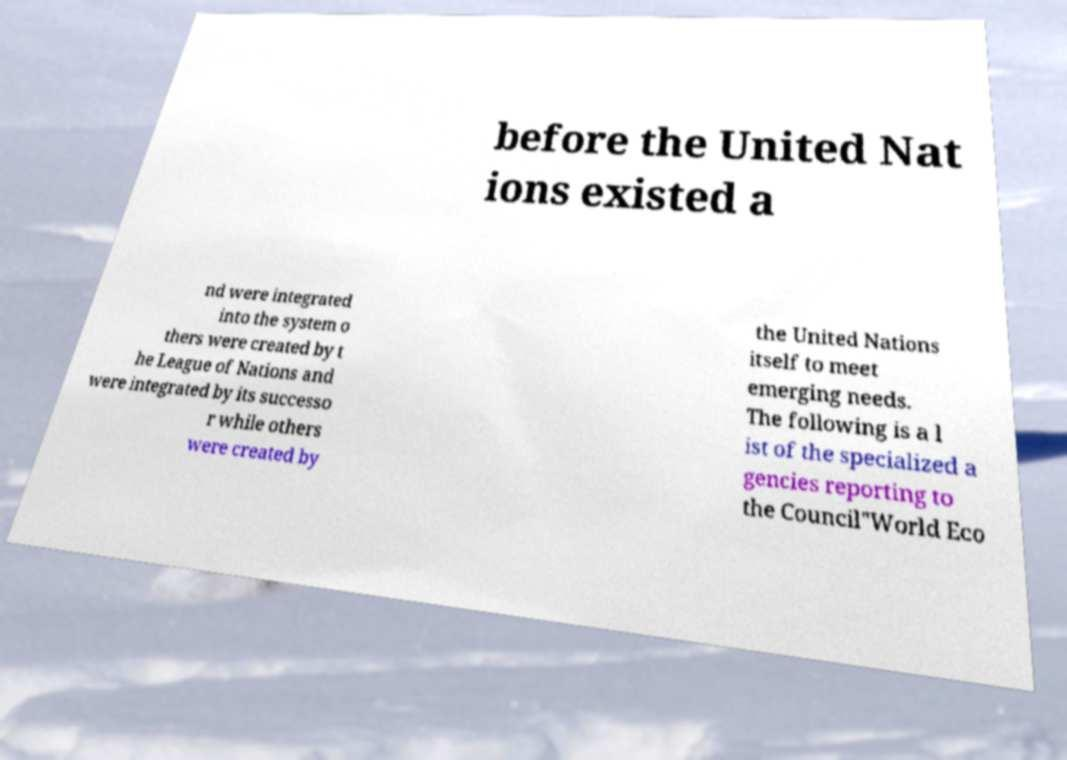Can you accurately transcribe the text from the provided image for me? before the United Nat ions existed a nd were integrated into the system o thers were created by t he League of Nations and were integrated by its successo r while others were created by the United Nations itself to meet emerging needs. The following is a l ist of the specialized a gencies reporting to the Council"World Eco 